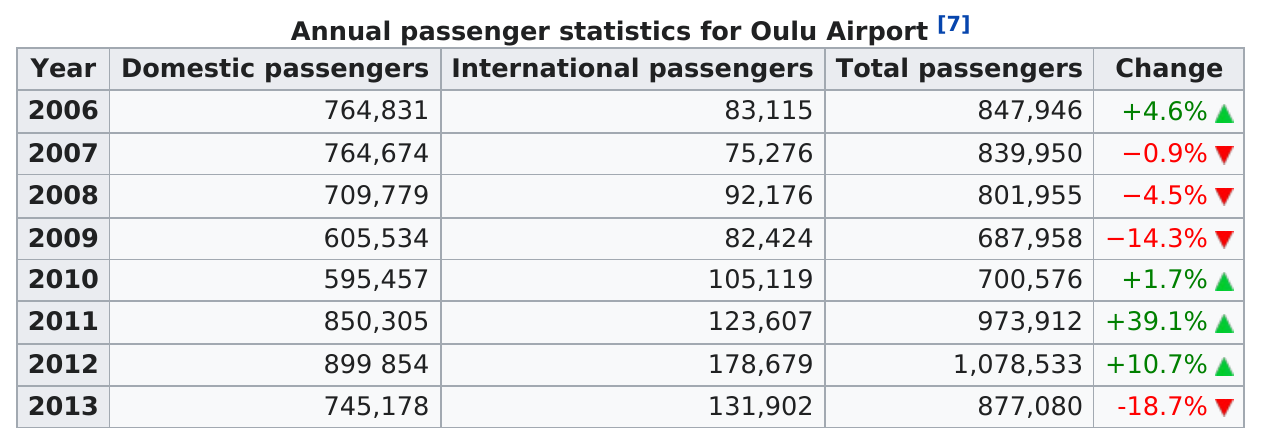Give some essential details in this illustration. In 2006, there were approximately 80,000 international passengers, and in 2009, there were also around 80,000 international passengers. Oulu Airport experienced an increase in total passengers for three consecutive years. Over the past 4 years, there has been a positive increase. Eight years of statistics are listed in the chart. In 2013, the total number of passengers decreased the most compared to the previous year, marking the highest drop in passenger volume in that particular year. 